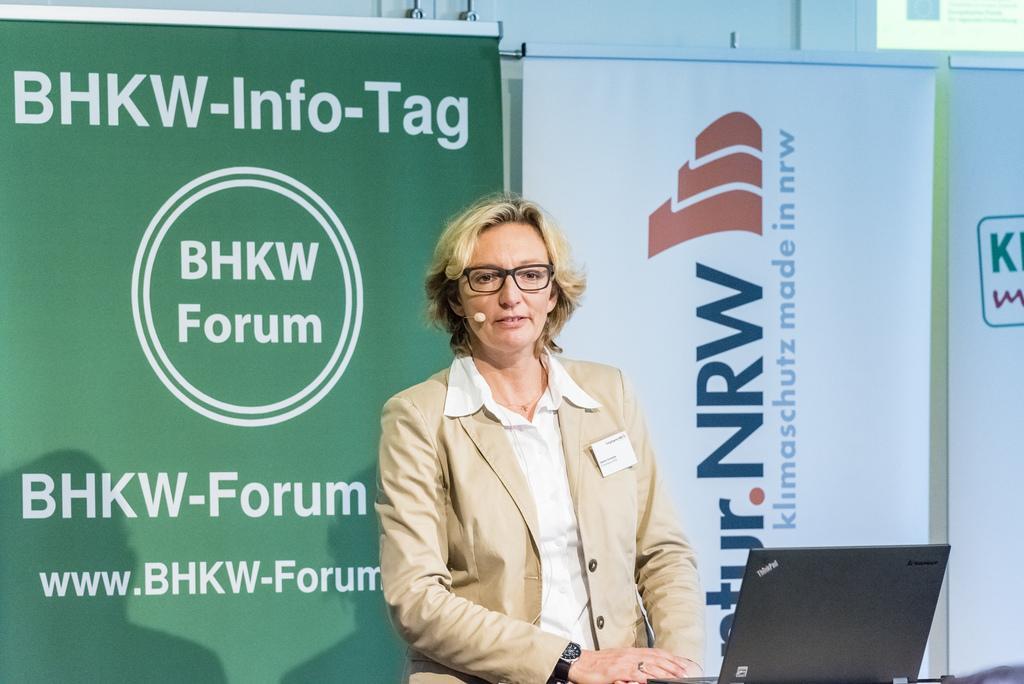Describe this image in one or two sentences. In the picture I can see a woman is standing and wearing a coat, spectacles, a microphone, a watch and some other objects. Here I can see a laptop. In the background I can see banners which has something written on them. 